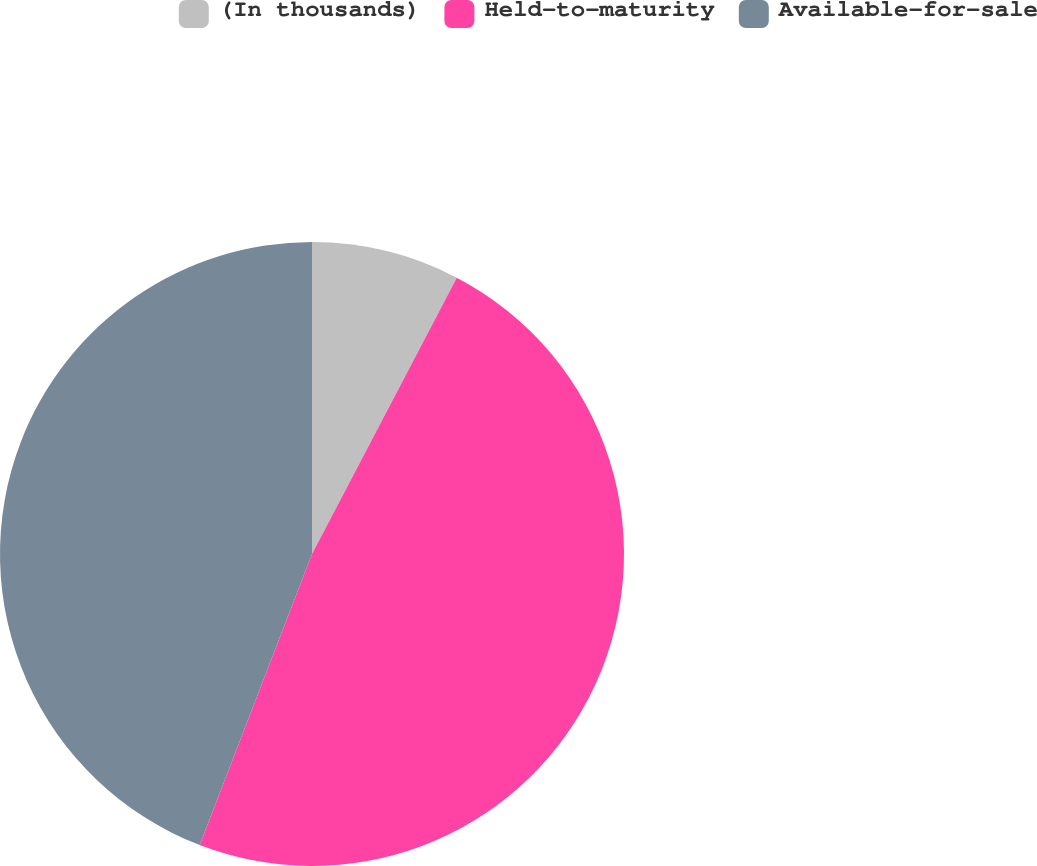Convert chart. <chart><loc_0><loc_0><loc_500><loc_500><pie_chart><fcel>(In thousands)<fcel>Held-to-maturity<fcel>Available-for-sale<nl><fcel>7.68%<fcel>48.18%<fcel>44.14%<nl></chart> 